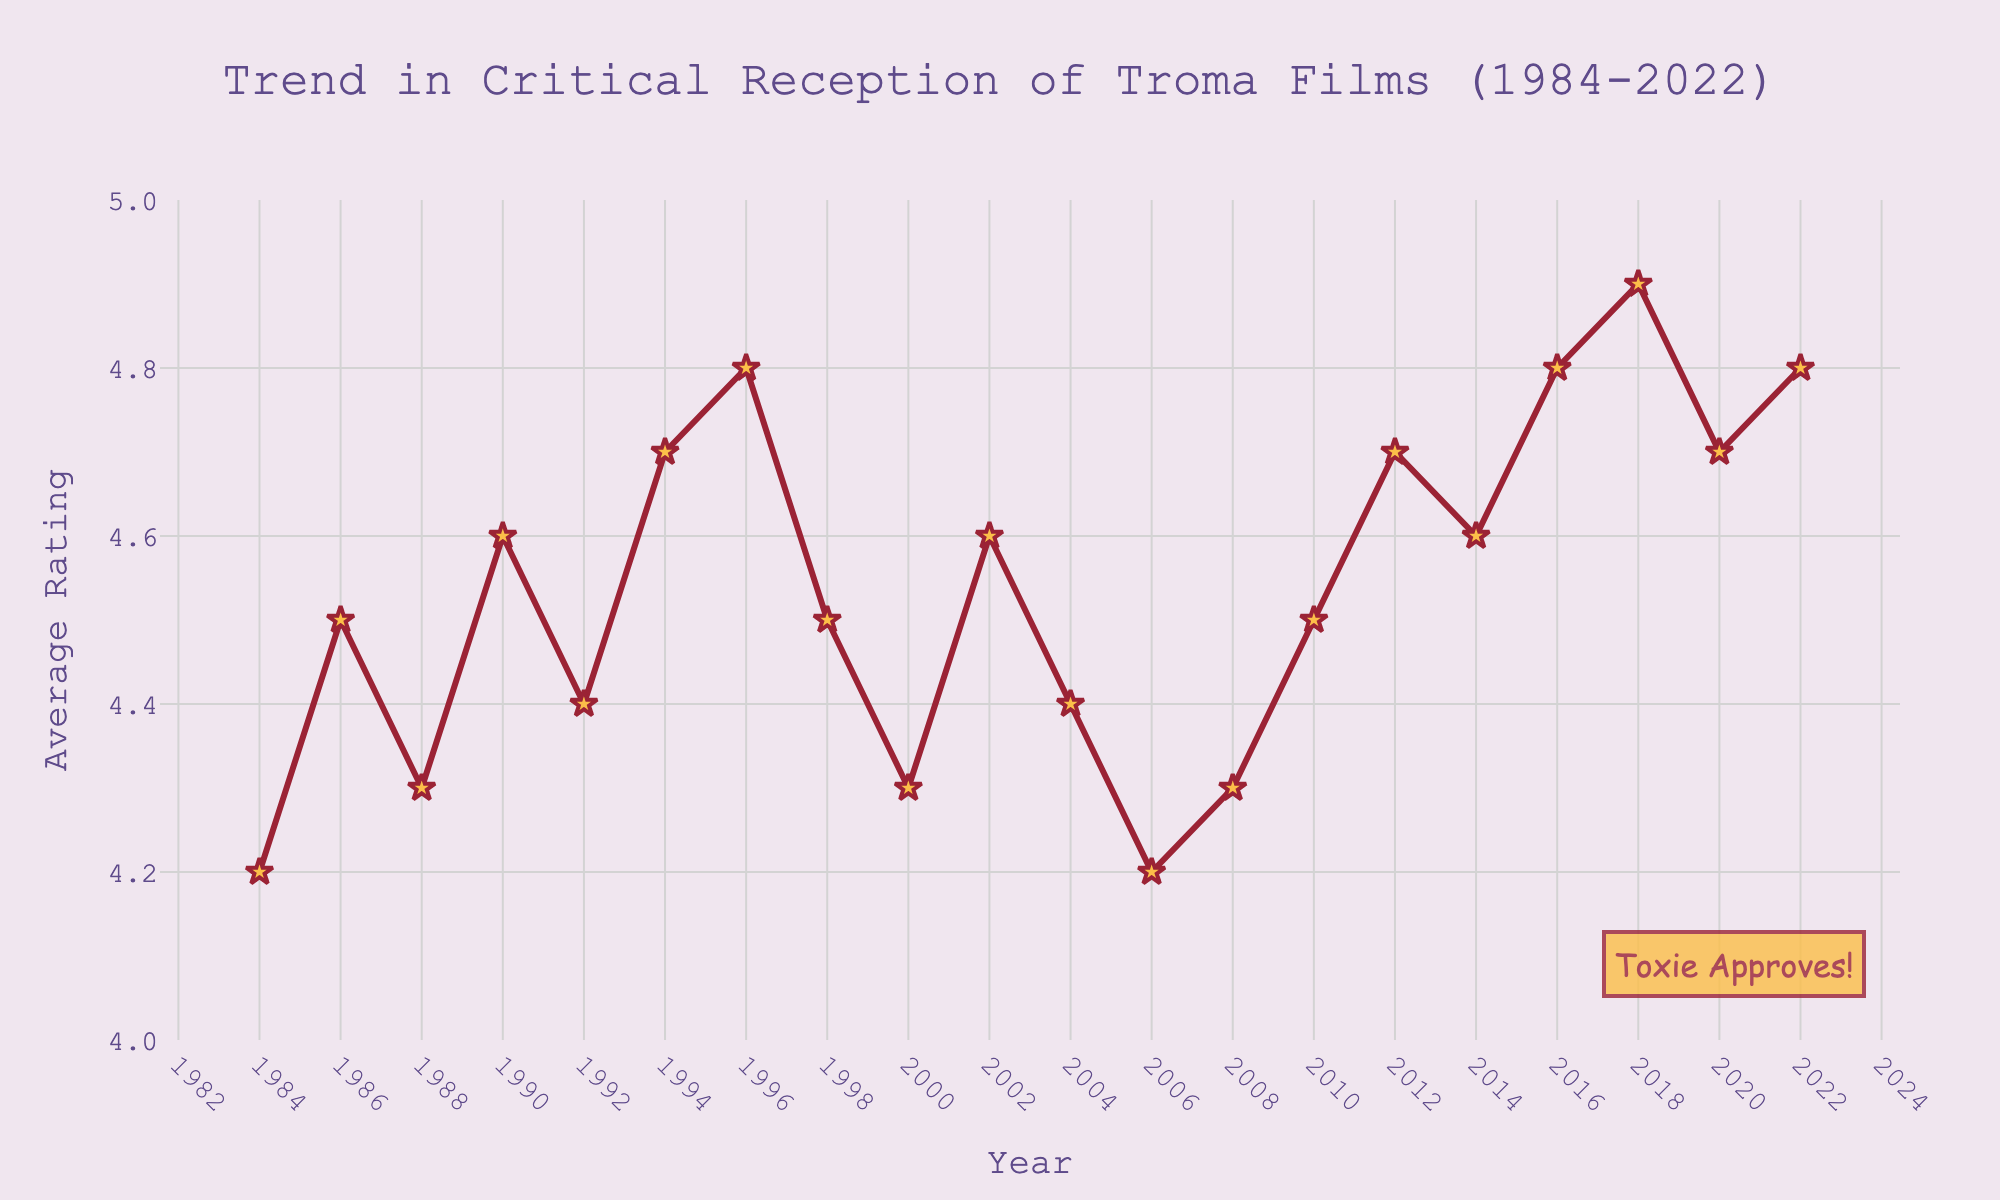what year had the highest average rating? Look at the data points on the figure. The highest point on the y-axis corresponds to the year 2018 with an average rating of 4.9.
Answer: 2018 how many years had an average rating of 4.7? Identify the years with an average rating of 4.7: 1994, 2012, and 2020, totaling to three years.
Answer: 3 what is the average rating difference between 1984 and 1996? Subtract the average rating of 1984 (4.2) from 1996 (4.8): 4.8 - 4.2 = 0.6.
Answer: 0.6 which year showed the first increase in average rating after 2006? The immediate year after 2006 is 2008, which increased from 4.2 to 4.3.
Answer: 2008 between 2006 and 2010, what is the overall trend in average rating? From 2006 (4.2) to 2010 (4.5), the ratings show an overall increasing trend.
Answer: Increasing which year had a decline in average rating compared to the previous data point? Average ratings of 1998 (4.5), 2000 (4.3), and 2006 (4.2) show a decline from their respective previous years.
Answer: 1998, 2000, 2006 how many years saw an average rating of 4.8 or higher? Identify years with average ratings of 4.8 or higher: 1996, 2016, 2018, and 2022, totaling four years.
Answer: 4 what was the average rating trend between 2004 and 2014? From 2004 (4.4) to 2014 (4.6), the ratings initially decrease and then increase, resulting in an overall increasing trend.
Answer: Increasing which year had the closest rating to 4.5 but not exactly 4.5? Identify the years with average ratings closest to 4.5: 2004 (4.4), 1988 (4.3), 2002 (4.6), and 2008 (4.3), with 2004 being the closest (4.4).
Answer: 2004 was there any year where the average rating remained the same as the previous year? No visible data points indicate two consecutive years with identical average ratings.
Answer: No 